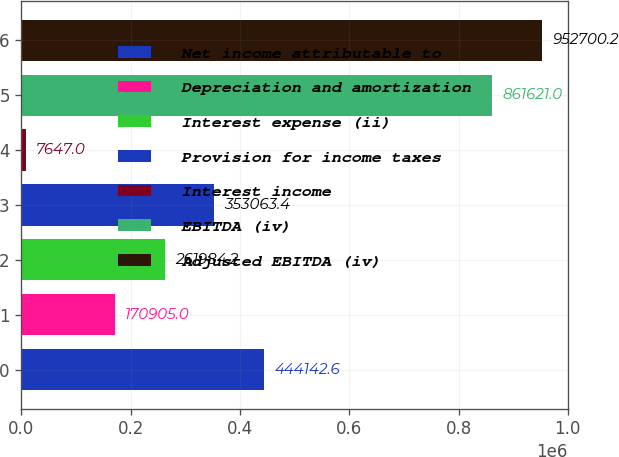Convert chart. <chart><loc_0><loc_0><loc_500><loc_500><bar_chart><fcel>Net income attributable to<fcel>Depreciation and amortization<fcel>Interest expense (ii)<fcel>Provision for income taxes<fcel>Interest income<fcel>EBITDA (iv)<fcel>Adjusted EBITDA (iv)<nl><fcel>444143<fcel>170905<fcel>261984<fcel>353063<fcel>7647<fcel>861621<fcel>952700<nl></chart> 